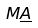<formula> <loc_0><loc_0><loc_500><loc_500>M \underline { A }</formula> 